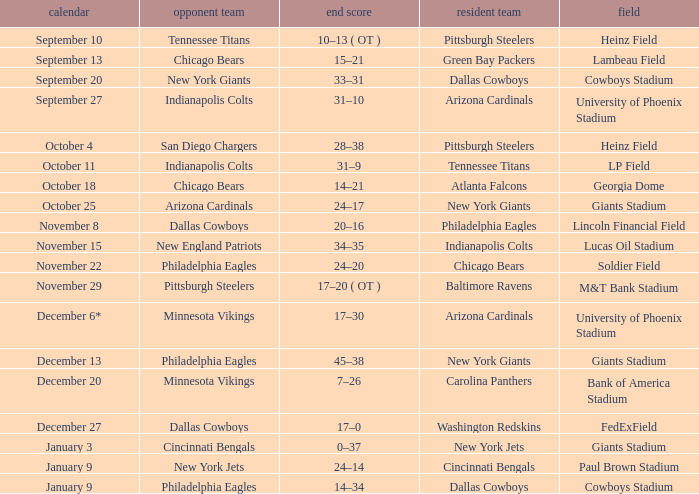Tell me the date for pittsburgh steelers November 29. 